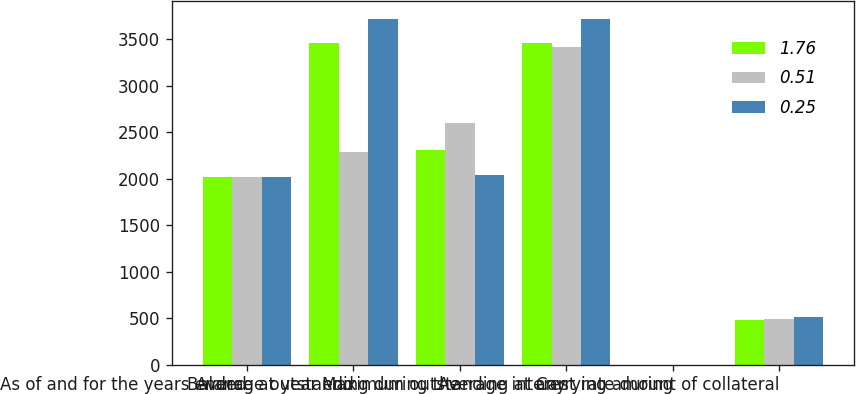<chart> <loc_0><loc_0><loc_500><loc_500><stacked_bar_chart><ecel><fcel>As of and for the years ended<fcel>Balance at year end<fcel>Average outstanding during the<fcel>Maximum outstanding at any<fcel>Average interest rate during<fcel>Carrying amount of collateral<nl><fcel>1.76<fcel>2015<fcel>3463.8<fcel>2306.6<fcel>3463.8<fcel>0.42<fcel>478.9<nl><fcel>0.51<fcel>2014<fcel>2291.7<fcel>2593.7<fcel>3419.5<fcel>0.36<fcel>495.7<nl><fcel>0.25<fcel>2013<fcel>3719.8<fcel>2043.9<fcel>3719.8<fcel>0.4<fcel>511.2<nl></chart> 